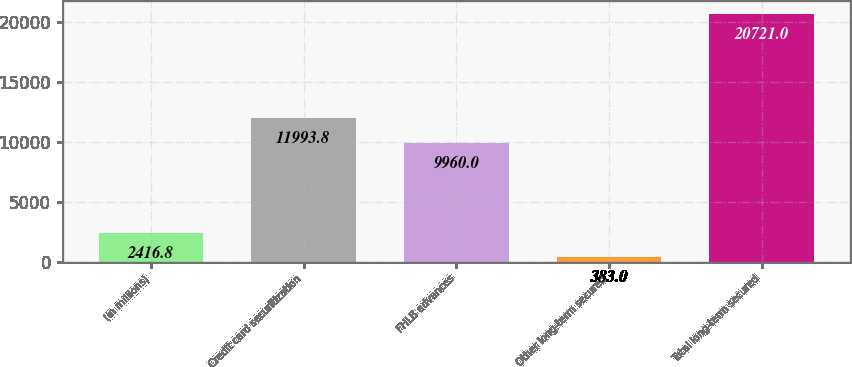Convert chart to OTSL. <chart><loc_0><loc_0><loc_500><loc_500><bar_chart><fcel>(in millions)<fcel>Credit card securitization<fcel>FHLB advances<fcel>Other long-term secured<fcel>Total long-term secured<nl><fcel>2416.8<fcel>11993.8<fcel>9960<fcel>383<fcel>20721<nl></chart> 